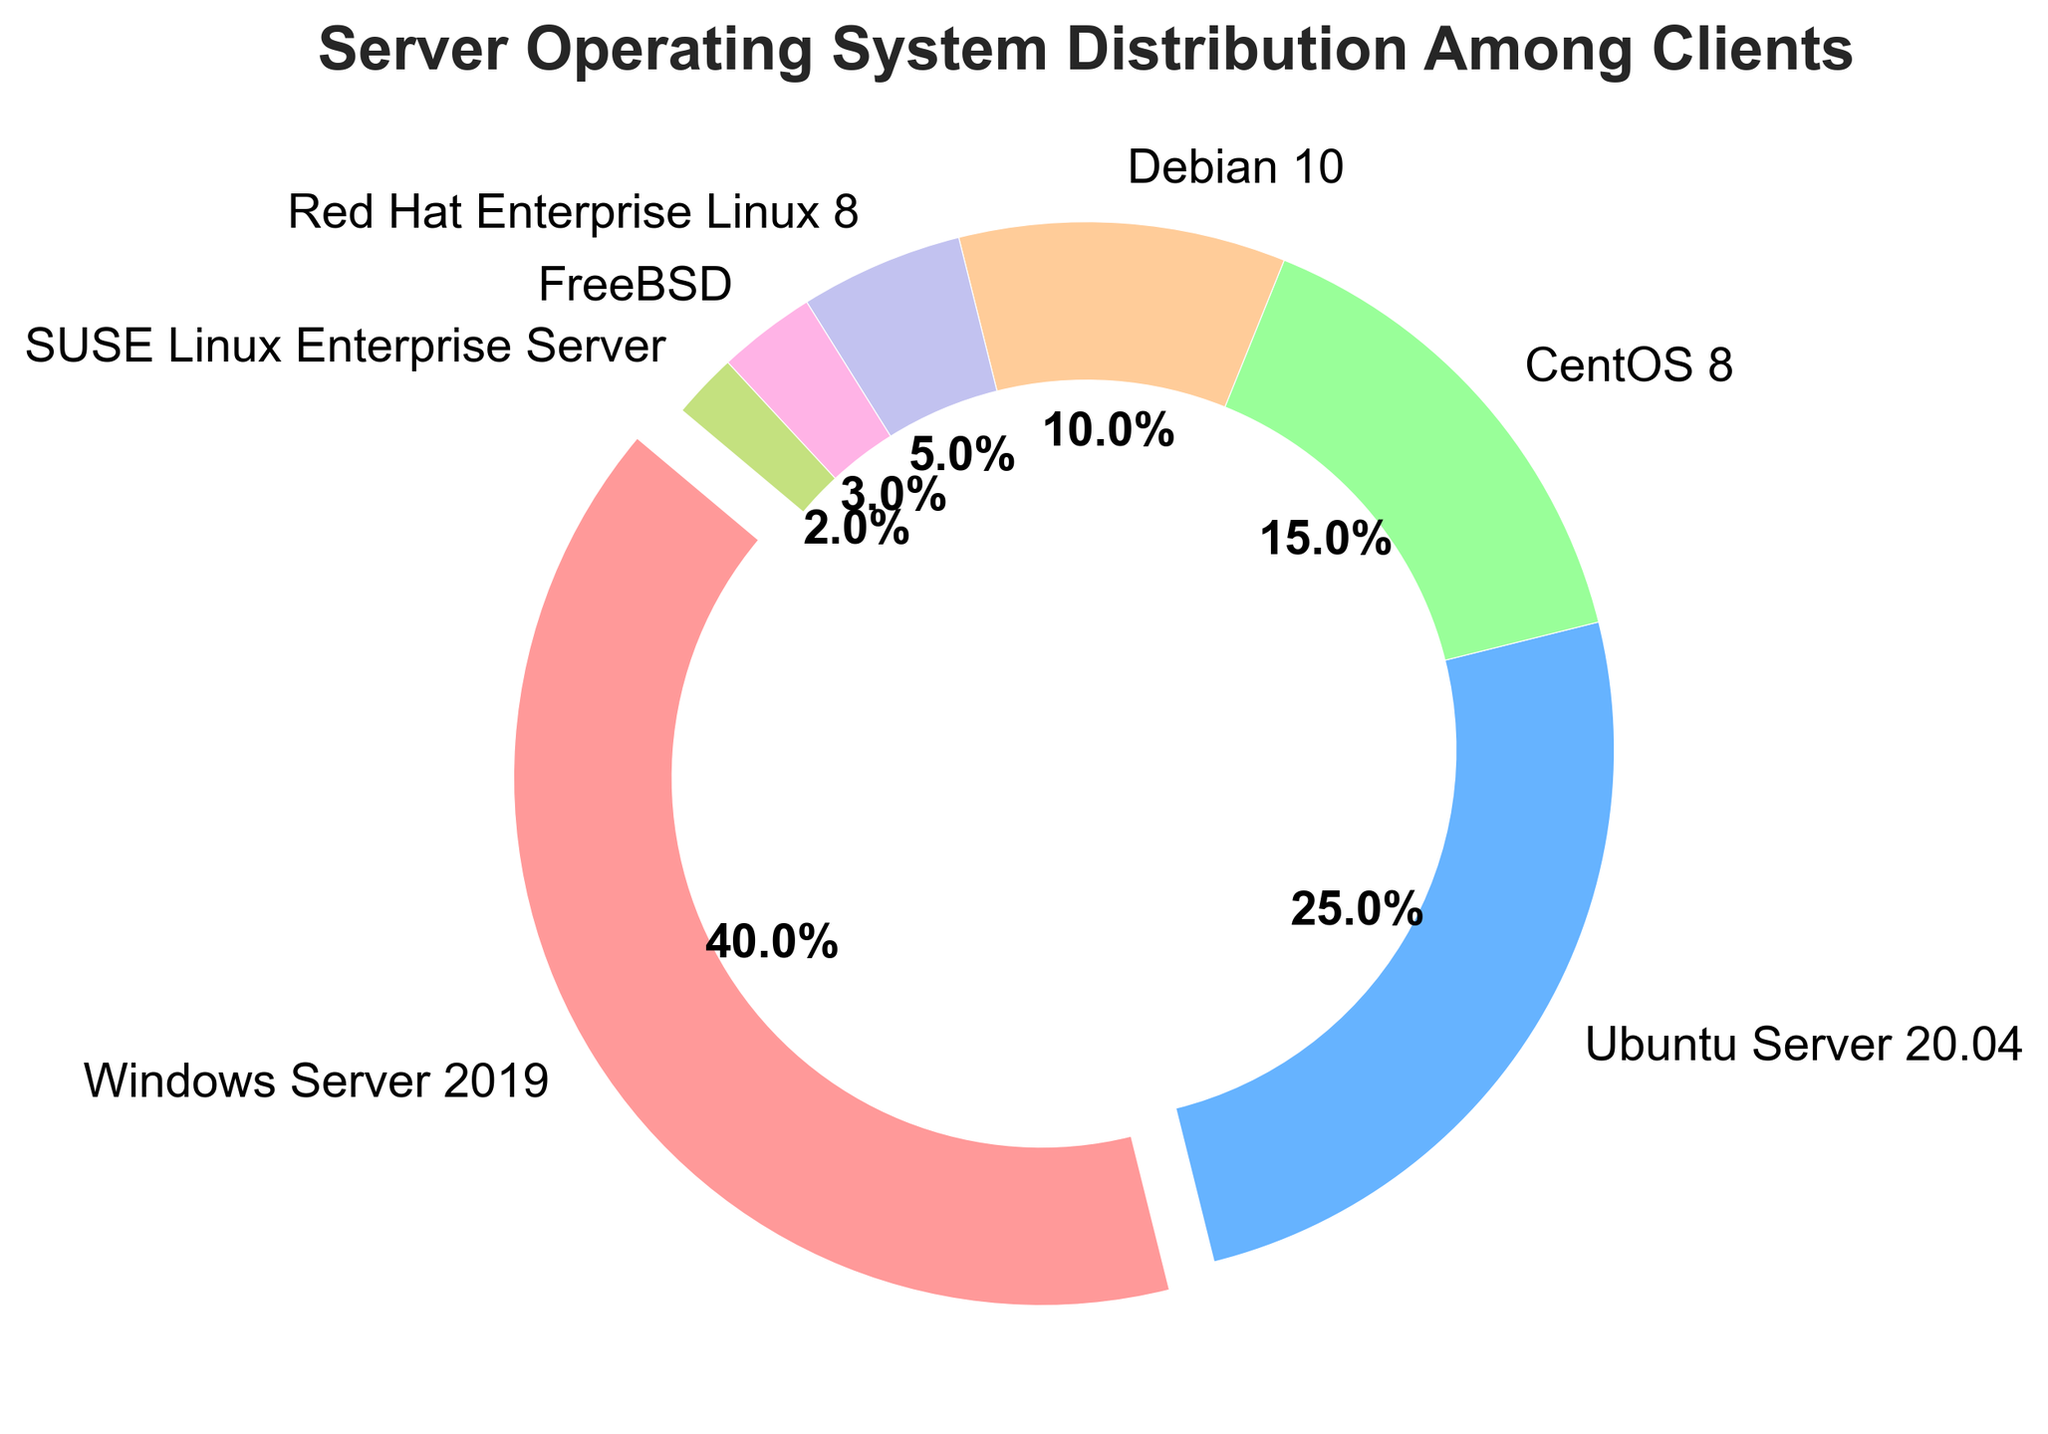Which operating system has the largest market share among clients? The chart shows the percentages for different server operating systems, and Windows Server 2019 has the largest slice, indicating the highest percentage.
Answer: Windows Server 2019 What is the combined percentage of Ubuntu Server 20.04 and CentOS 8? Ubuntu Server 20.04 has 25% and CentOS 8 has 15%. Adding them together gives 25% + 15% = 40%.
Answer: 40% Which operating system has the smallest market share? From the pie chart, SUSE Linux Enterprise Server has the smallest slice, which means it has the smallest market share.
Answer: SUSE Linux Enterprise Server Are there more clients using Debian 10 or FreeBSD? The chart shows that Debian 10 has 10% and FreeBSD has 3%. Therefore, more clients use Debian 10.
Answer: Debian 10 How does the market share of Red Hat Enterprise Linux 8 compare to that of Ubuntu Server 20.04? Red Hat Enterprise Linux 8 has a 5% share, while Ubuntu Server 20.04 has a 25% share. Comparing the two, Ubuntu Server 20.04 has a higher market share.
Answer: Ubuntu Server 20.04 What is the difference in percentage between the most and least popular operating systems? The most popular is Windows Server 2019 with 40%, and the least popular is SUSE Linux Enterprise Server with 2%. The difference is 40% - 2% = 38%.
Answer: 38% If we combined the market shares of CentOS 8, Debian 10, and FreeBSD, what would their total share be? CentOS 8 has 15%, Debian 10 has 10%, and FreeBSD has 3%. Adding them together gives 15% + 10% + 3% = 28%.
Answer: 28% How much larger is the slice for CentOS 8 than the slice for SUSE Linux Enterprise Server? CentOS 8 has 15%, and SUSE Linux Enterprise Server has 2%. The difference is 15% - 2% = 13%.
Answer: 13% What visual cue is used to highlight the largest slice of the pie chart? The slice for Windows Server 2019, which is the largest, is slightly separated from the rest of the pie slices to highlight it.
Answer: It is exploded Does any operating system share the same color as another? Each operating system has a different color slice in the pie chart, as seen from the color legend.
Answer: No 